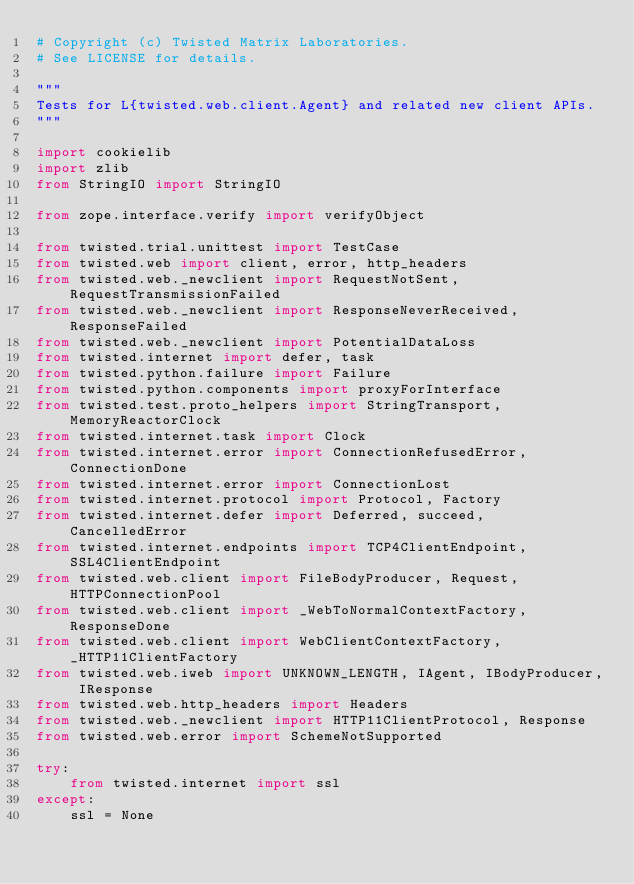Convert code to text. <code><loc_0><loc_0><loc_500><loc_500><_Python_># Copyright (c) Twisted Matrix Laboratories.
# See LICENSE for details.

"""
Tests for L{twisted.web.client.Agent} and related new client APIs.
"""

import cookielib
import zlib
from StringIO import StringIO

from zope.interface.verify import verifyObject

from twisted.trial.unittest import TestCase
from twisted.web import client, error, http_headers
from twisted.web._newclient import RequestNotSent, RequestTransmissionFailed
from twisted.web._newclient import ResponseNeverReceived, ResponseFailed
from twisted.web._newclient import PotentialDataLoss
from twisted.internet import defer, task
from twisted.python.failure import Failure
from twisted.python.components import proxyForInterface
from twisted.test.proto_helpers import StringTransport, MemoryReactorClock
from twisted.internet.task import Clock
from twisted.internet.error import ConnectionRefusedError, ConnectionDone
from twisted.internet.error import ConnectionLost
from twisted.internet.protocol import Protocol, Factory
from twisted.internet.defer import Deferred, succeed, CancelledError
from twisted.internet.endpoints import TCP4ClientEndpoint, SSL4ClientEndpoint
from twisted.web.client import FileBodyProducer, Request, HTTPConnectionPool
from twisted.web.client import _WebToNormalContextFactory, ResponseDone
from twisted.web.client import WebClientContextFactory, _HTTP11ClientFactory
from twisted.web.iweb import UNKNOWN_LENGTH, IAgent, IBodyProducer, IResponse
from twisted.web.http_headers import Headers
from twisted.web._newclient import HTTP11ClientProtocol, Response
from twisted.web.error import SchemeNotSupported

try:
    from twisted.internet import ssl
except:
    ssl = None


</code> 